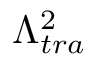<formula> <loc_0><loc_0><loc_500><loc_500>\Lambda _ { t r a } ^ { 2 }</formula> 